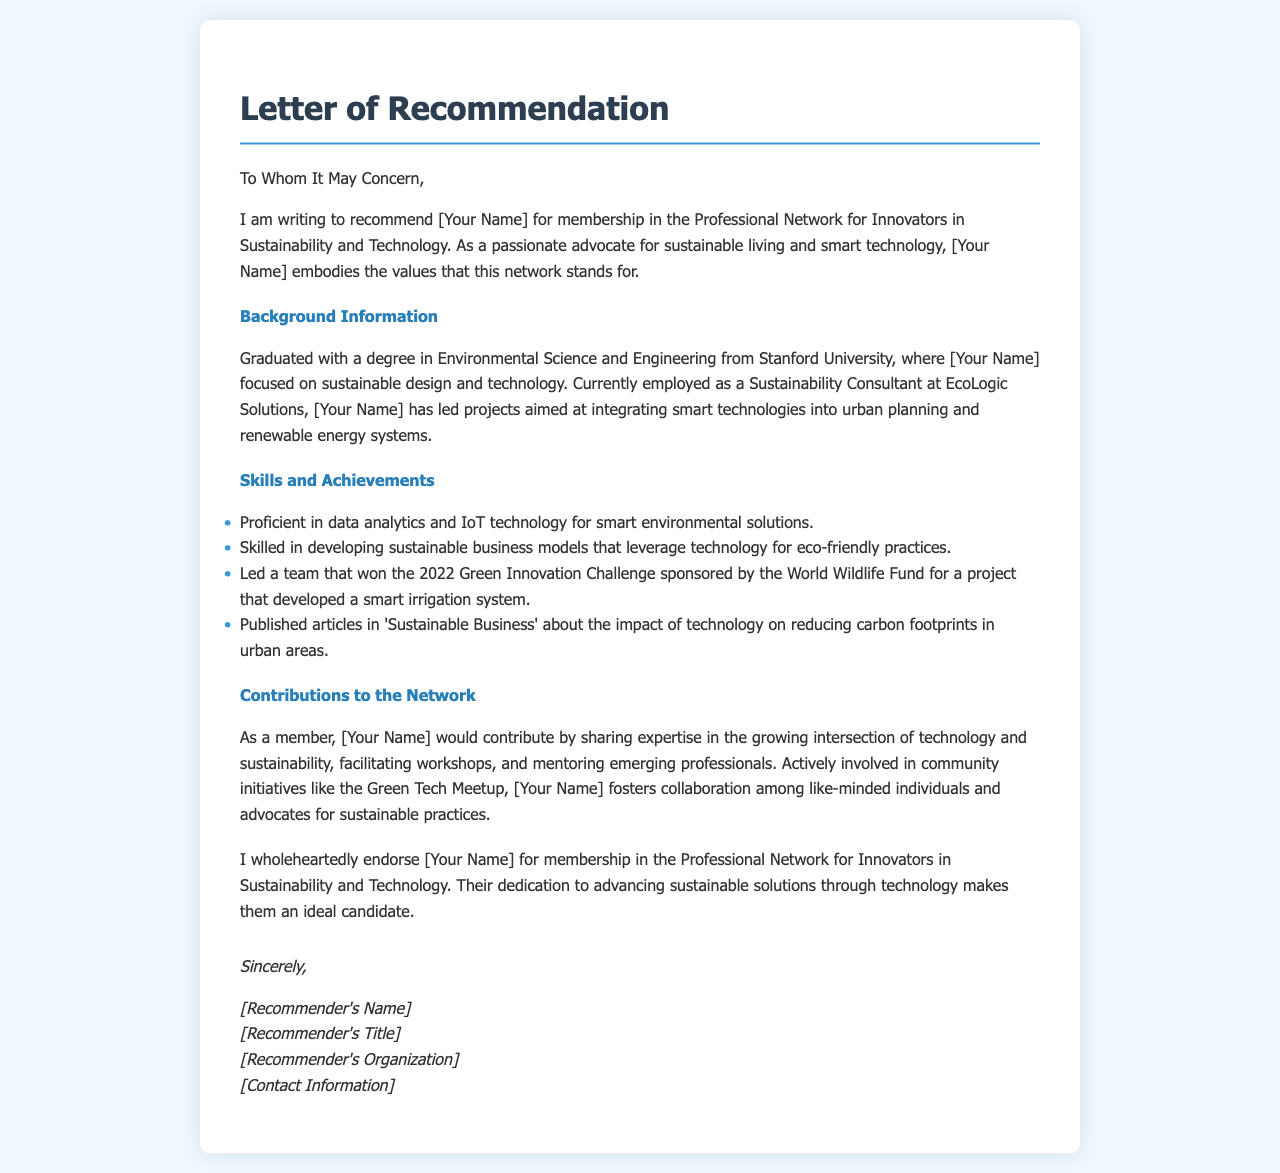What is the name of the person being recommended? The letter refers to the person being recommended as [Your Name], a placeholder for the actual name.
Answer: [Your Name] What degree did the person graduate with? The letter states that the person graduated with a degree in Environmental Science and Engineering.
Answer: Environmental Science and Engineering What organization is the person currently employed by? The document mentions that the person is employed at EcoLogic Solutions.
Answer: EcoLogic Solutions Which challenge did the team win in 2022? The letter indicates that the team won the 2022 Green Innovation Challenge sponsored by the World Wildlife Fund.
Answer: 2022 Green Innovation Challenge What type of technology is the person proficient in? The letter notes proficiency in data analytics and IoT technology.
Answer: data analytics and IoT technology What is one way the person plans to contribute to the network? The letter mentions that the person would facilitate workshops as one of their contributions.
Answer: facilitate workshops What is the title of the recommender? The letter includes a placeholder for the recommender's title as [Recommender's Title].
Answer: [Recommender's Title] What is the main theme of the letter? The overall theme is recommending [Your Name] for membership in the Professional Network for Innovators in Sustainability and Technology.
Answer: recommendation for membership What initiative is the person actively involved in? The document refers to the person's involvement in the Green Tech Meetup.
Answer: Green Tech Meetup 